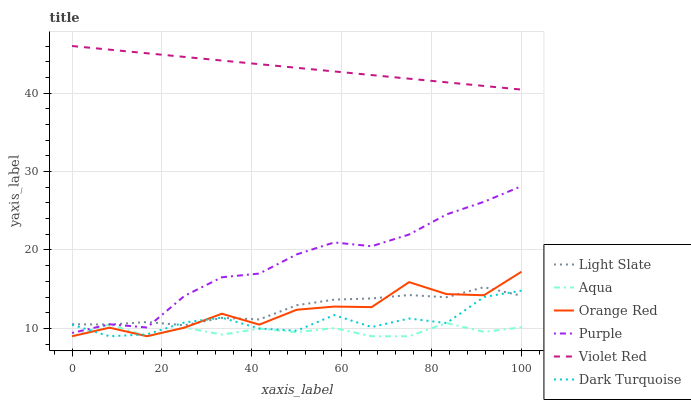Does Aqua have the minimum area under the curve?
Answer yes or no. Yes. Does Violet Red have the maximum area under the curve?
Answer yes or no. Yes. Does Light Slate have the minimum area under the curve?
Answer yes or no. No. Does Light Slate have the maximum area under the curve?
Answer yes or no. No. Is Violet Red the smoothest?
Answer yes or no. Yes. Is Orange Red the roughest?
Answer yes or no. Yes. Is Light Slate the smoothest?
Answer yes or no. No. Is Light Slate the roughest?
Answer yes or no. No. Does Dark Turquoise have the lowest value?
Answer yes or no. Yes. Does Light Slate have the lowest value?
Answer yes or no. No. Does Violet Red have the highest value?
Answer yes or no. Yes. Does Light Slate have the highest value?
Answer yes or no. No. Is Aqua less than Purple?
Answer yes or no. Yes. Is Violet Red greater than Aqua?
Answer yes or no. Yes. Does Dark Turquoise intersect Aqua?
Answer yes or no. Yes. Is Dark Turquoise less than Aqua?
Answer yes or no. No. Is Dark Turquoise greater than Aqua?
Answer yes or no. No. Does Aqua intersect Purple?
Answer yes or no. No. 